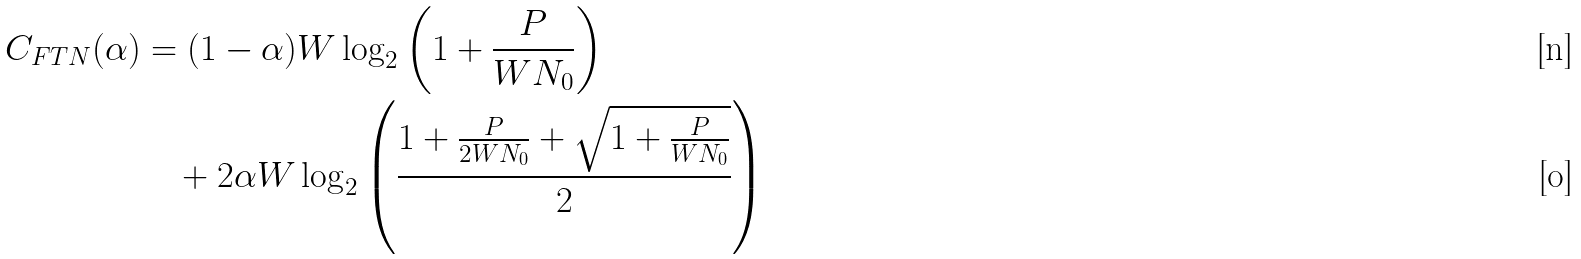Convert formula to latex. <formula><loc_0><loc_0><loc_500><loc_500>C _ { F T N } ( \alpha ) & = ( 1 - \alpha ) W \log _ { 2 } \left ( 1 + \frac { P } { W N _ { 0 } } \right ) \\ & \quad + 2 \alpha W \log _ { 2 } \left ( \frac { 1 + \frac { P } { 2 W N _ { 0 } } + \sqrt { 1 + \frac { P } { W N _ { 0 } } } } { 2 } \right )</formula> 